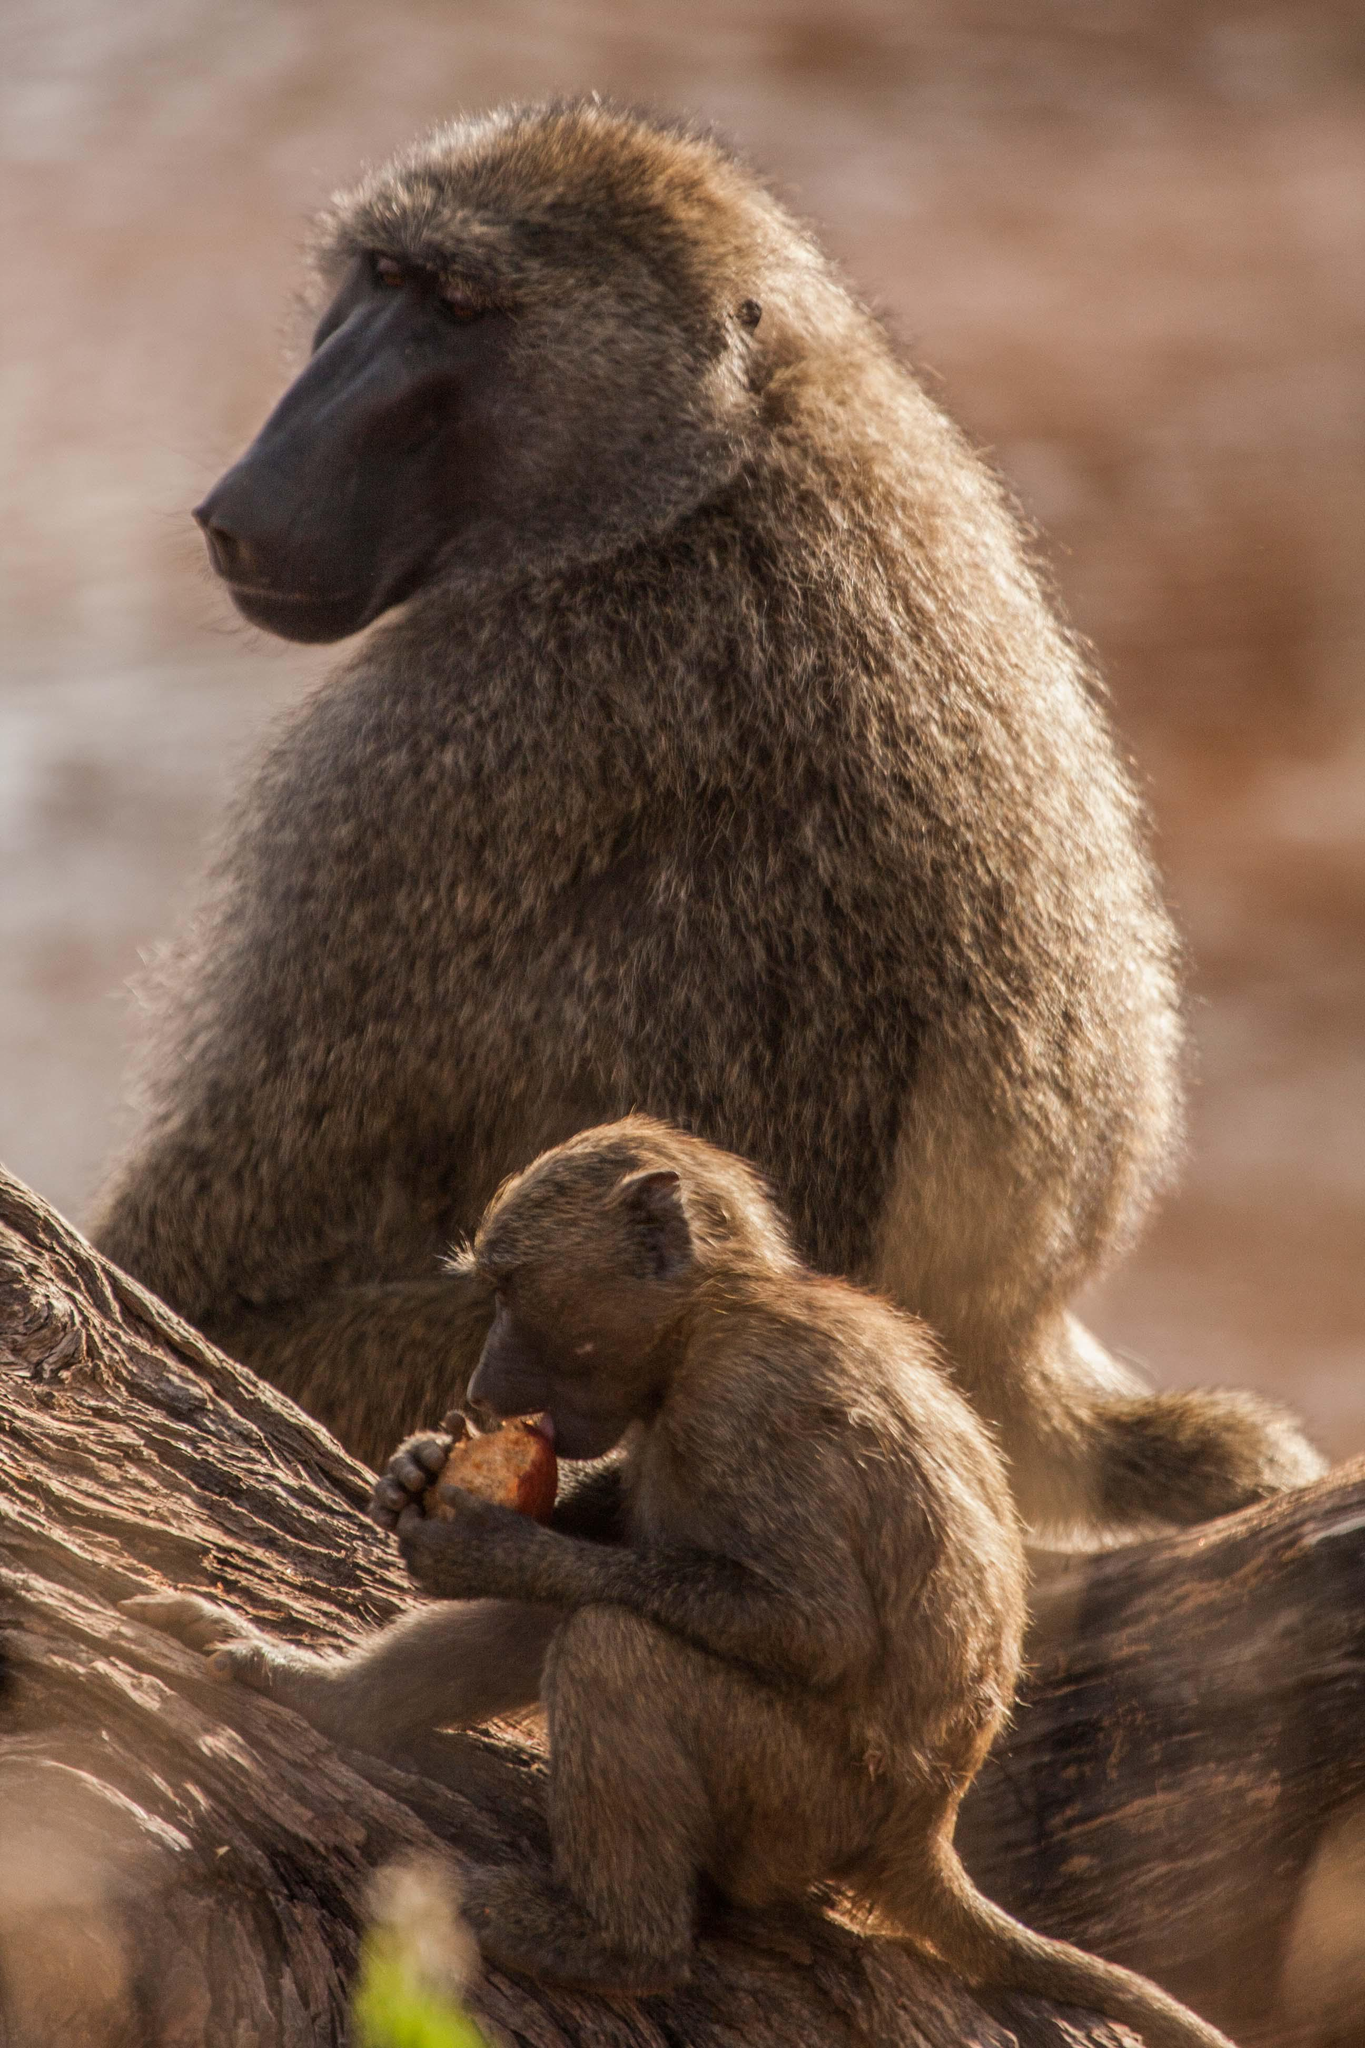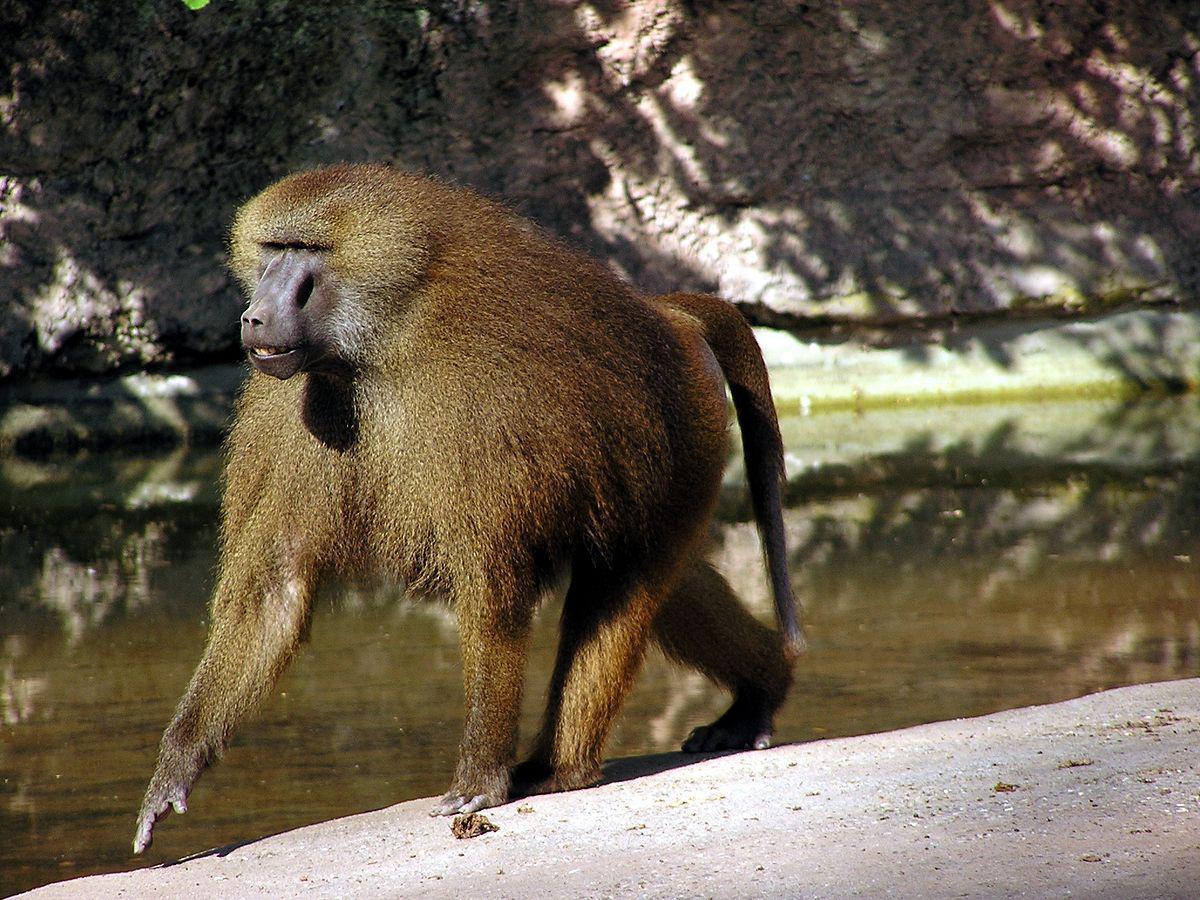The first image is the image on the left, the second image is the image on the right. Given the left and right images, does the statement "One image shows baboons in the water creating splashes, and at least one of those monkeys has its tail raised." hold true? Answer yes or no. No. The first image is the image on the left, the second image is the image on the right. Assess this claim about the two images: "An image contains exactly one primate.". Correct or not? Answer yes or no. Yes. 